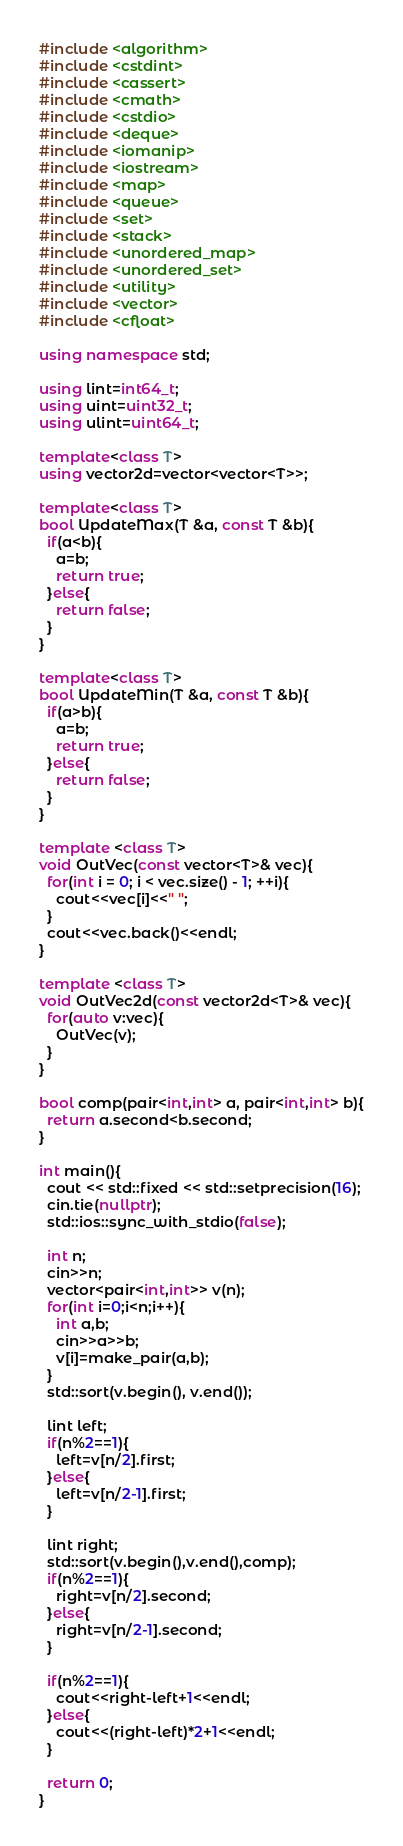<code> <loc_0><loc_0><loc_500><loc_500><_C++_>#include <algorithm>
#include <cstdint>
#include <cassert>
#include <cmath>
#include <cstdio>
#include <deque>
#include <iomanip>
#include <iostream>
#include <map>
#include <queue>
#include <set>
#include <stack>
#include <unordered_map>
#include <unordered_set>
#include <utility>
#include <vector>
#include <cfloat>

using namespace std;

using lint=int64_t;
using uint=uint32_t;
using ulint=uint64_t;

template<class T>
using vector2d=vector<vector<T>>;

template<class T>
bool UpdateMax(T &a, const T &b){
  if(a<b){
    a=b;
    return true;
  }else{
    return false;
  }
}

template<class T>
bool UpdateMin(T &a, const T &b){
  if(a>b){
    a=b;
    return true;
  }else{
    return false;
  }
}

template <class T>
void OutVec(const vector<T>& vec){
  for(int i = 0; i < vec.size() - 1; ++i){
    cout<<vec[i]<<" ";
  }
  cout<<vec.back()<<endl;
}

template <class T>
void OutVec2d(const vector2d<T>& vec){
  for(auto v:vec){
    OutVec(v);
  }
}

bool comp(pair<int,int> a, pair<int,int> b){
  return a.second<b.second;
}

int main(){
  cout << std::fixed << std::setprecision(16);
  cin.tie(nullptr);
  std::ios::sync_with_stdio(false);

  int n;
  cin>>n;
  vector<pair<int,int>> v(n);
  for(int i=0;i<n;i++){
    int a,b;
    cin>>a>>b;
    v[i]=make_pair(a,b);
  }
  std::sort(v.begin(), v.end());

  lint left;
  if(n%2==1){
    left=v[n/2].first;
  }else{
    left=v[n/2-1].first;
  }

  lint right;
  std::sort(v.begin(),v.end(),comp);
  if(n%2==1){
    right=v[n/2].second;
  }else{
    right=v[n/2-1].second;
  }

  if(n%2==1){
    cout<<right-left+1<<endl;
  }else{
    cout<<(right-left)*2+1<<endl;
  }

  return 0;
}


</code> 